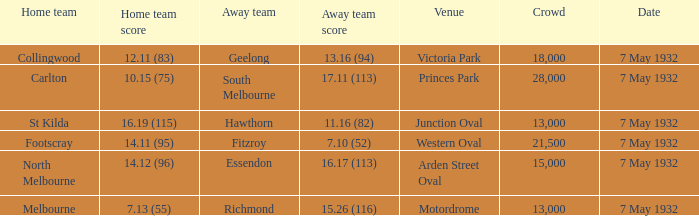Which home team has an opponent team of hawthorn? St Kilda. Give me the full table as a dictionary. {'header': ['Home team', 'Home team score', 'Away team', 'Away team score', 'Venue', 'Crowd', 'Date'], 'rows': [['Collingwood', '12.11 (83)', 'Geelong', '13.16 (94)', 'Victoria Park', '18,000', '7 May 1932'], ['Carlton', '10.15 (75)', 'South Melbourne', '17.11 (113)', 'Princes Park', '28,000', '7 May 1932'], ['St Kilda', '16.19 (115)', 'Hawthorn', '11.16 (82)', 'Junction Oval', '13,000', '7 May 1932'], ['Footscray', '14.11 (95)', 'Fitzroy', '7.10 (52)', 'Western Oval', '21,500', '7 May 1932'], ['North Melbourne', '14.12 (96)', 'Essendon', '16.17 (113)', 'Arden Street Oval', '15,000', '7 May 1932'], ['Melbourne', '7.13 (55)', 'Richmond', '15.26 (116)', 'Motordrome', '13,000', '7 May 1932']]} 